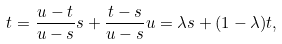<formula> <loc_0><loc_0><loc_500><loc_500>t = \frac { u - t } { u - s } s + \frac { t - s } { u - s } u = \lambda s + ( 1 - \lambda ) t ,</formula> 